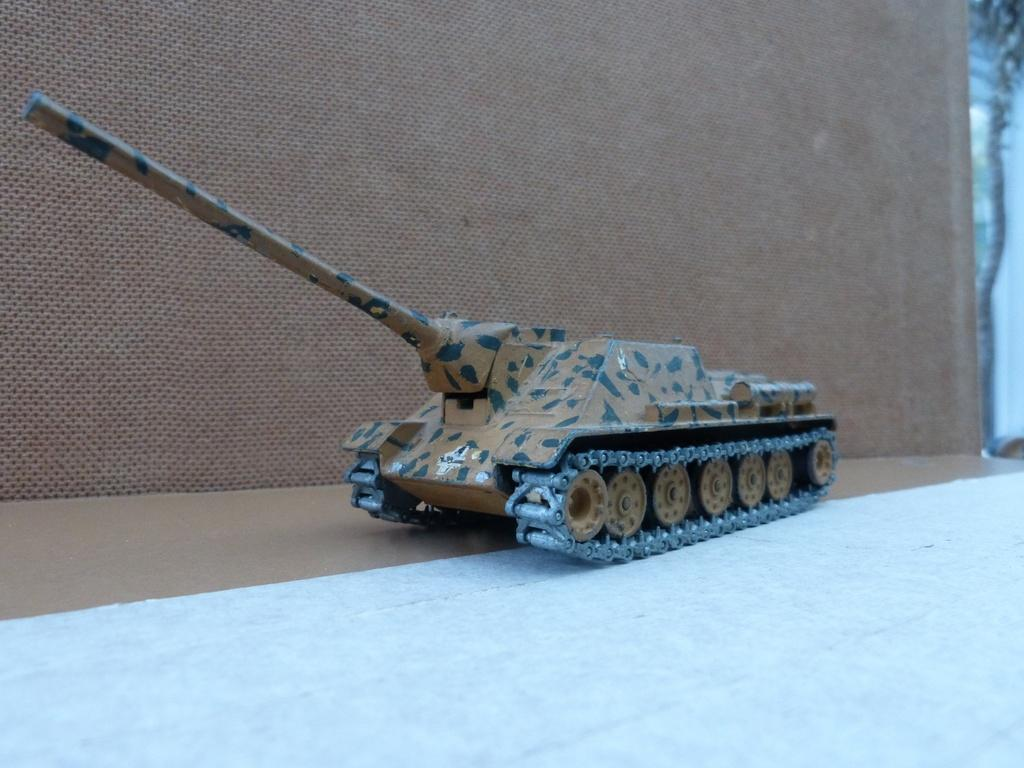What type of toy is present in the image? There is a toy of an army vehicle in the image. Can you describe the toy in more detail? The toy is an army vehicle, which typically has wheels and a military design. What type of pie is being served at the army vehicle's celebration in the image? There is no pie or celebration present in the image; it only features a toy of an army vehicle. 